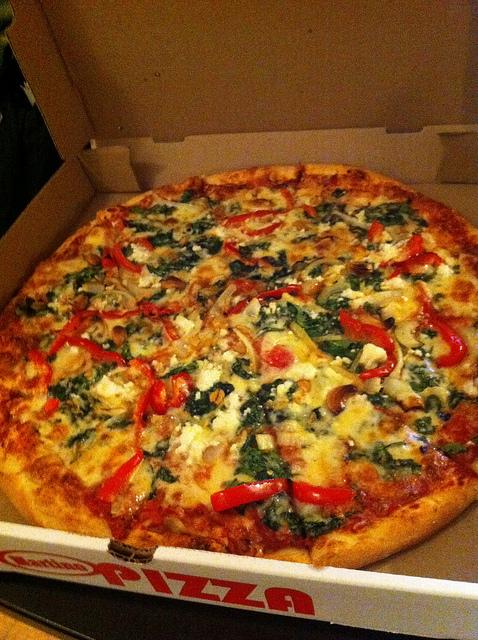Does the pizza have peppers?
Give a very brief answer. Yes. These pizzas appear to have come from which pizzeria?
Short answer required. Pizza. Is this a vegetarian pizza?
Quick response, please. Yes. What is in the box?
Be succinct. Pizza. 